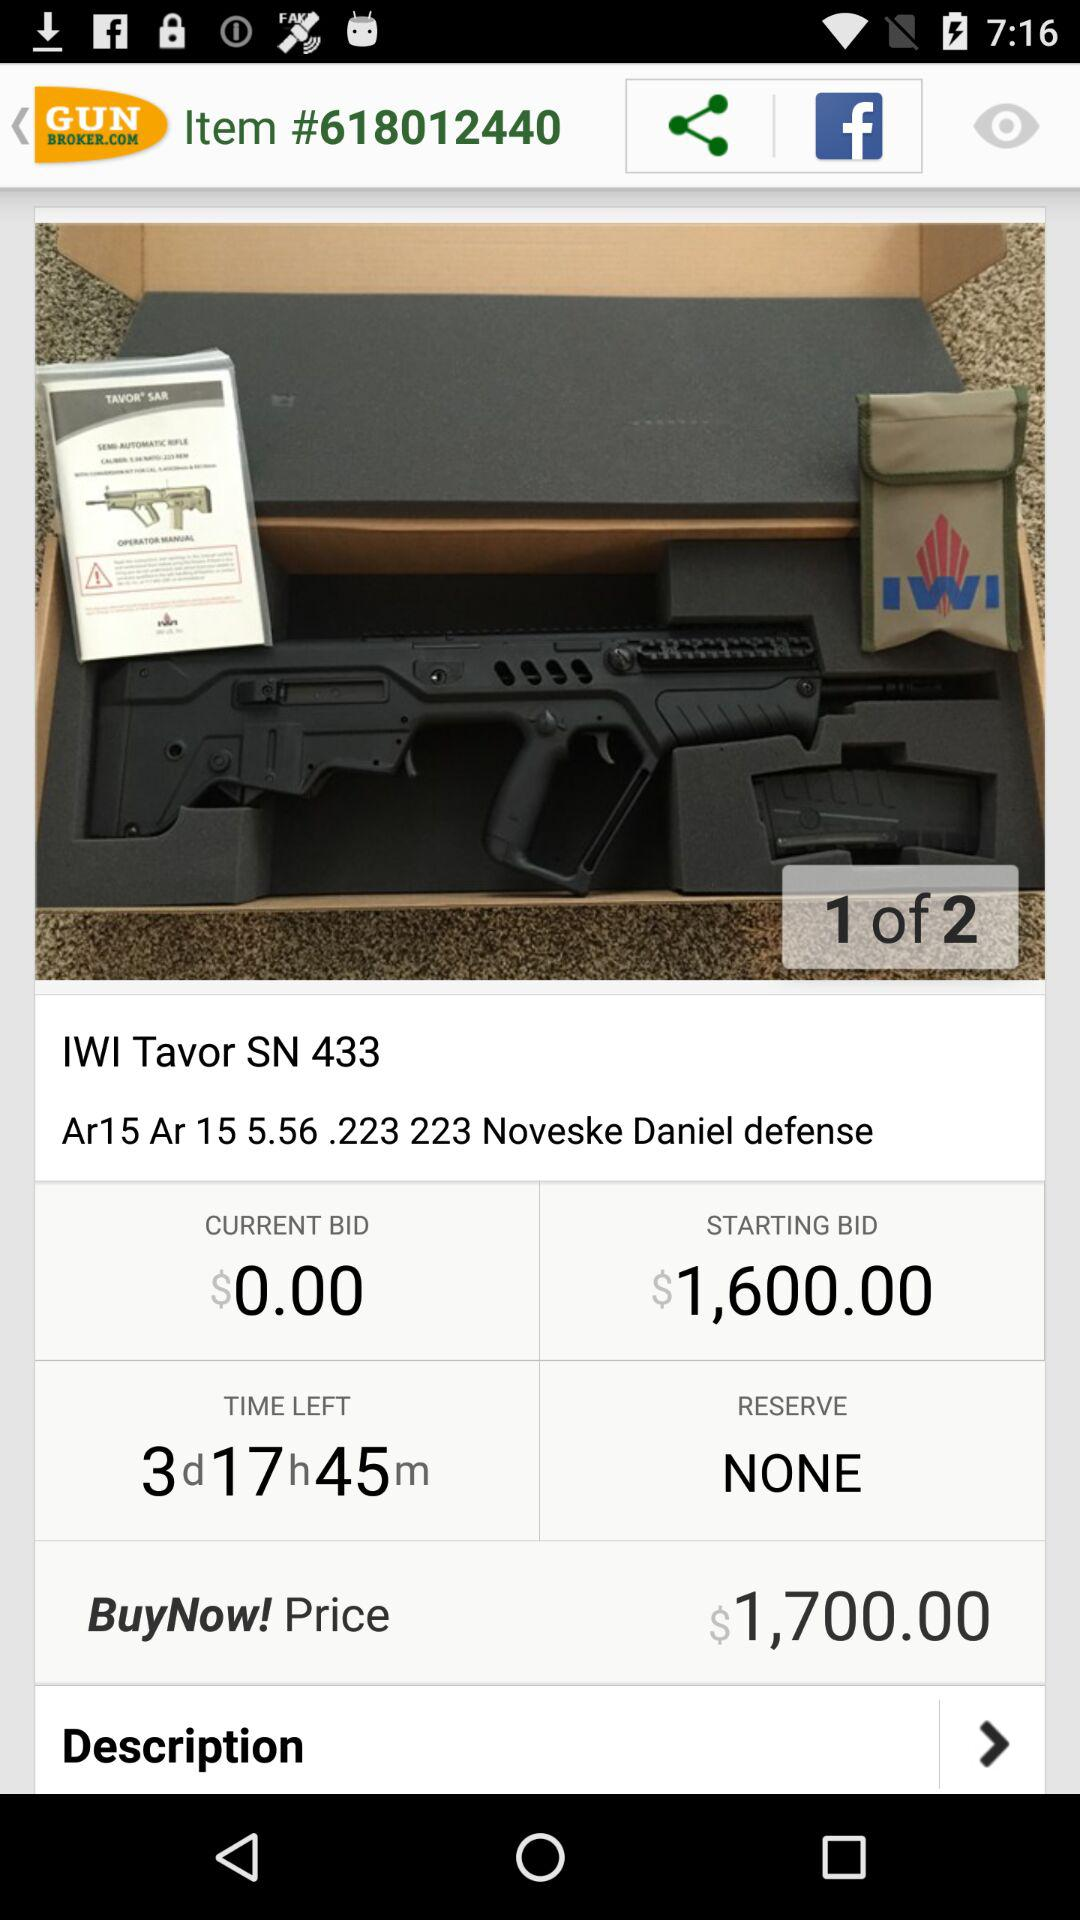What is the current bid price? The current bid price is $0.00. 